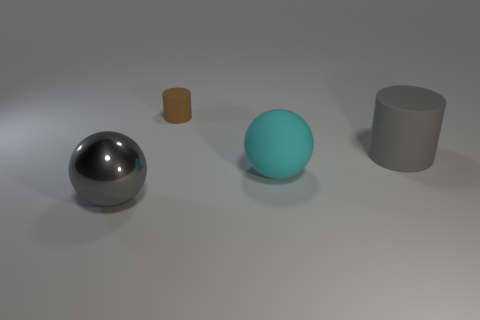There is a thing that is in front of the large cyan rubber ball; what shape is it?
Provide a succinct answer. Sphere. Are there any gray blocks made of the same material as the gray cylinder?
Your response must be concise. No. There is a cylinder that is on the right side of the cyan object; is it the same color as the big metallic ball?
Offer a terse response. Yes. What is the size of the brown rubber thing?
Offer a terse response. Small. There is a big sphere to the left of the big ball behind the large gray metallic sphere; is there a large gray cylinder behind it?
Your answer should be very brief. Yes. How many metallic objects are behind the cyan object?
Your response must be concise. 0. How many metal balls are the same color as the large cylinder?
Offer a very short reply. 1. What number of things are objects that are in front of the brown rubber object or big cyan matte spheres in front of the tiny matte thing?
Ensure brevity in your answer.  3. Are there more small brown rubber cylinders than things?
Offer a very short reply. No. What is the color of the ball on the left side of the cyan ball?
Keep it short and to the point. Gray. 